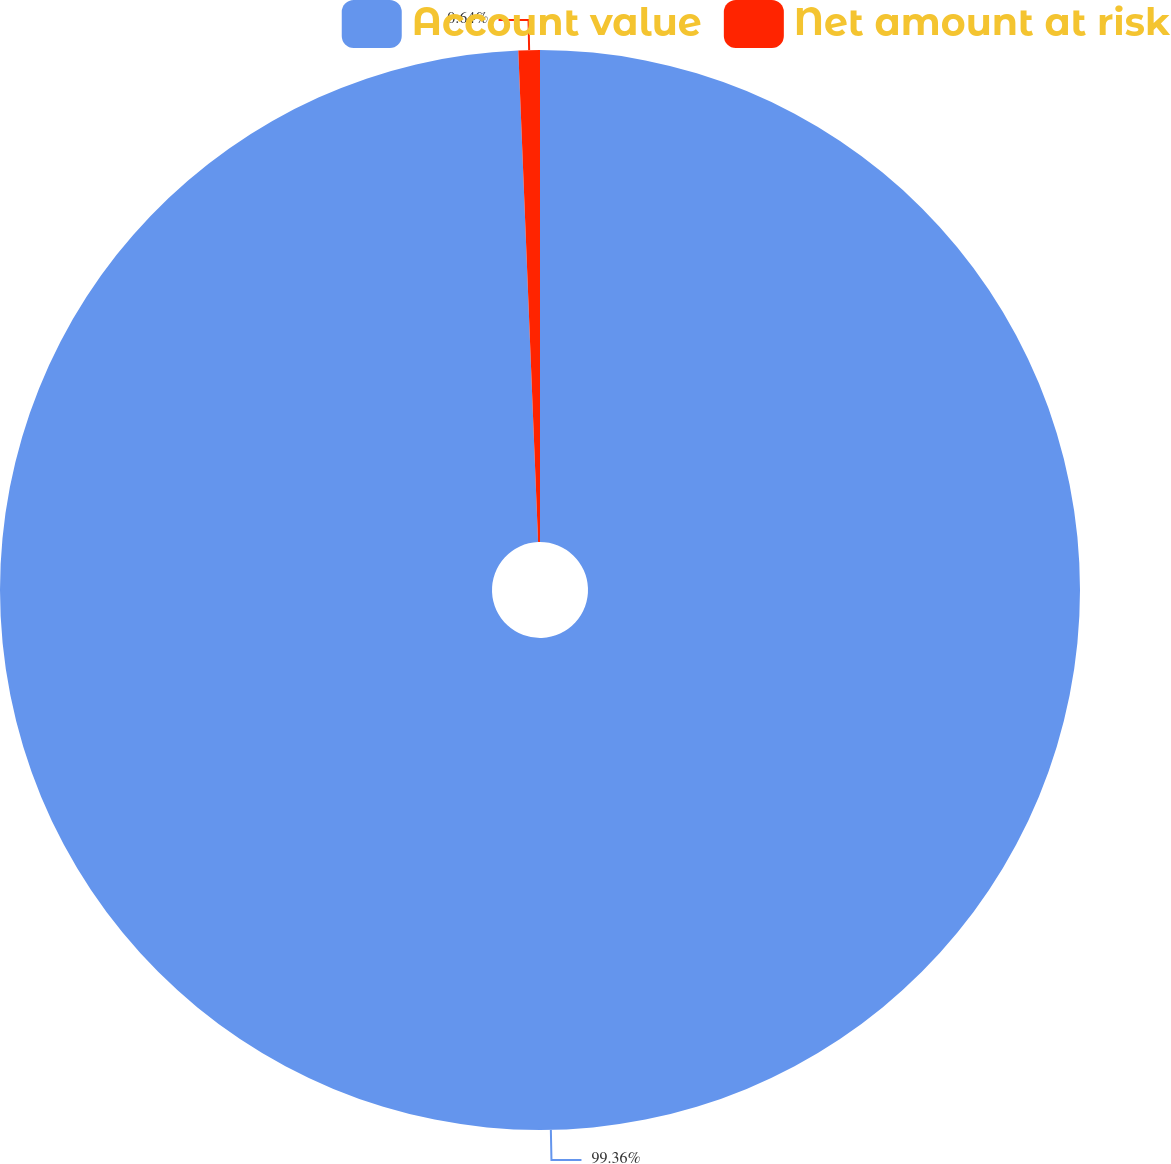Convert chart to OTSL. <chart><loc_0><loc_0><loc_500><loc_500><pie_chart><fcel>Account value<fcel>Net amount at risk<nl><fcel>99.36%<fcel>0.64%<nl></chart> 